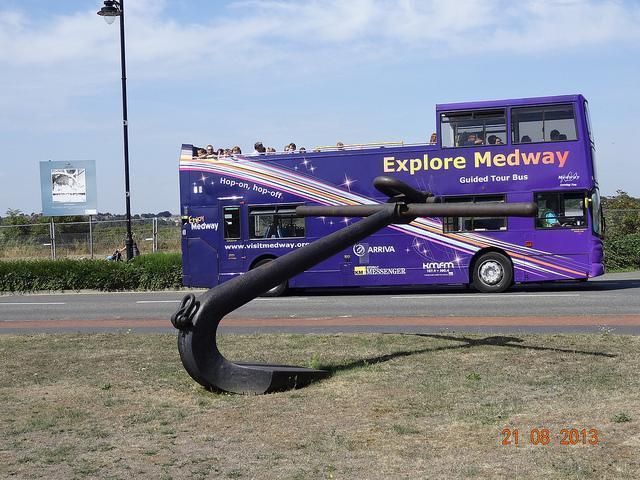How many chairs are standing with the table?
Give a very brief answer. 0. 